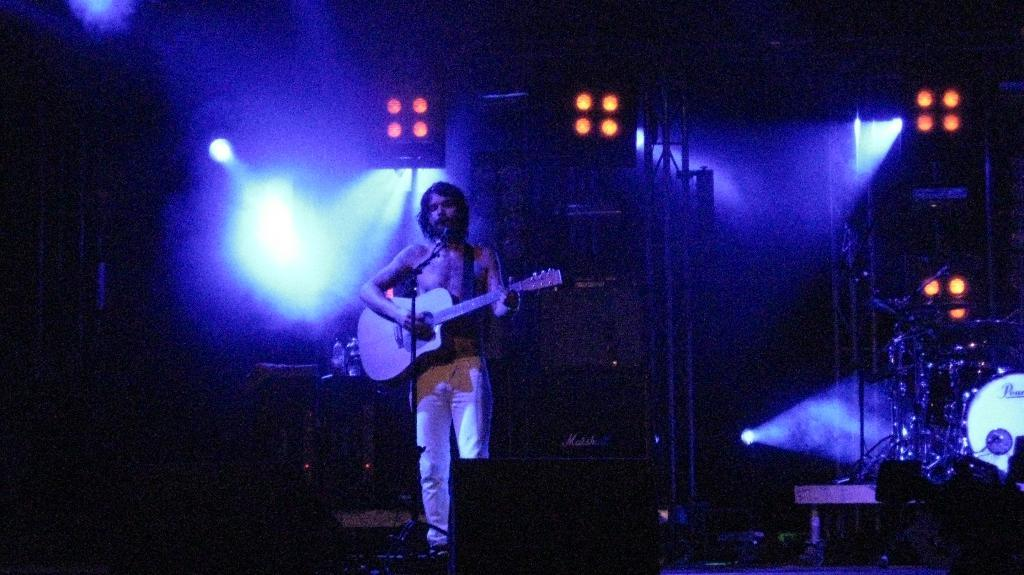What is the man in the image doing? The man is singing on a microphone and playing a guitar. What other objects related to music can be seen in the image? There are musical instruments in the image. Can you describe any other objects in the image? There is a bottle and lights visible in the image. What type of watch is the man wearing in the image? There is no watch visible on the man in the image. What game is being played in the image? There is no game being played in the image; it features a man singing and playing a guitar. 